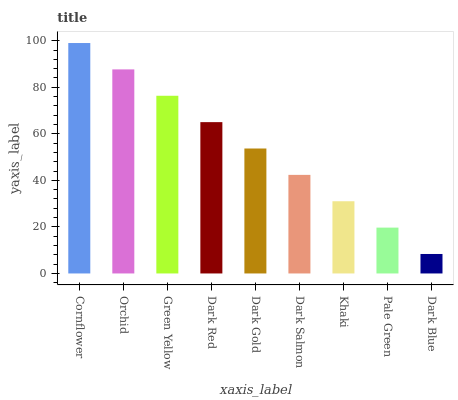Is Dark Blue the minimum?
Answer yes or no. Yes. Is Cornflower the maximum?
Answer yes or no. Yes. Is Orchid the minimum?
Answer yes or no. No. Is Orchid the maximum?
Answer yes or no. No. Is Cornflower greater than Orchid?
Answer yes or no. Yes. Is Orchid less than Cornflower?
Answer yes or no. Yes. Is Orchid greater than Cornflower?
Answer yes or no. No. Is Cornflower less than Orchid?
Answer yes or no. No. Is Dark Gold the high median?
Answer yes or no. Yes. Is Dark Gold the low median?
Answer yes or no. Yes. Is Dark Red the high median?
Answer yes or no. No. Is Khaki the low median?
Answer yes or no. No. 